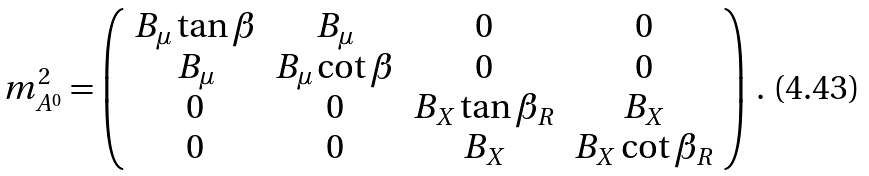<formula> <loc_0><loc_0><loc_500><loc_500>m ^ { 2 } _ { A ^ { 0 } } = \left ( \begin{array} { c c c c } B _ { \mu } \tan \beta & B _ { \mu } & 0 & 0 \\ B _ { \mu } & B _ { \mu } \cot \beta & 0 & 0 \\ 0 & 0 & B _ { X } \tan \beta _ { R } & B _ { X } \\ 0 & 0 & B _ { X } & B _ { X } \cot \beta _ { R } \end{array} \right ) \, .</formula> 